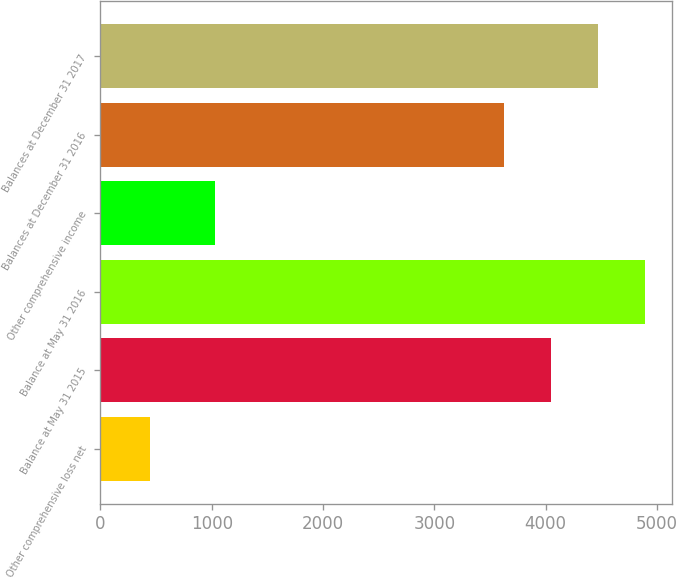Convert chart. <chart><loc_0><loc_0><loc_500><loc_500><bar_chart><fcel>Other comprehensive loss net<fcel>Balance at May 31 2015<fcel>Balance at May 31 2016<fcel>Other comprehensive income<fcel>Balances at December 31 2016<fcel>Balances at December 31 2017<nl><fcel>450<fcel>4047.7<fcel>4889.1<fcel>1030<fcel>3627<fcel>4468.4<nl></chart> 